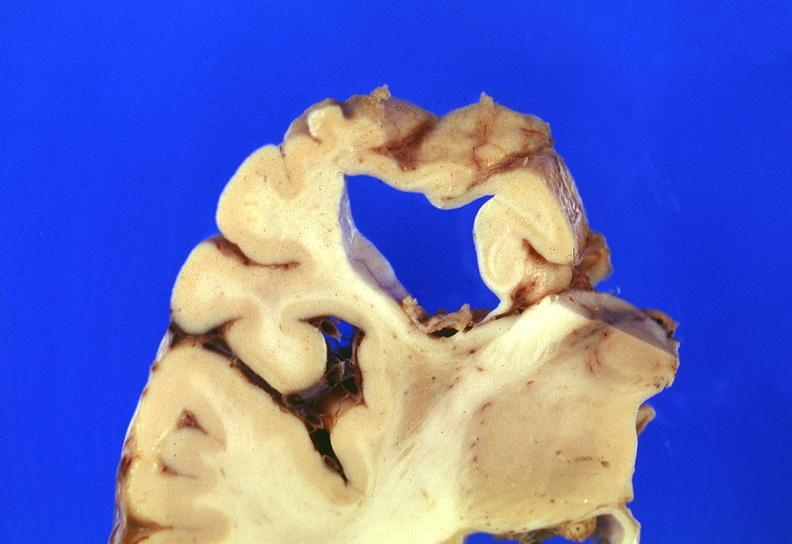s granulosa cell tumor present?
Answer the question using a single word or phrase. No 